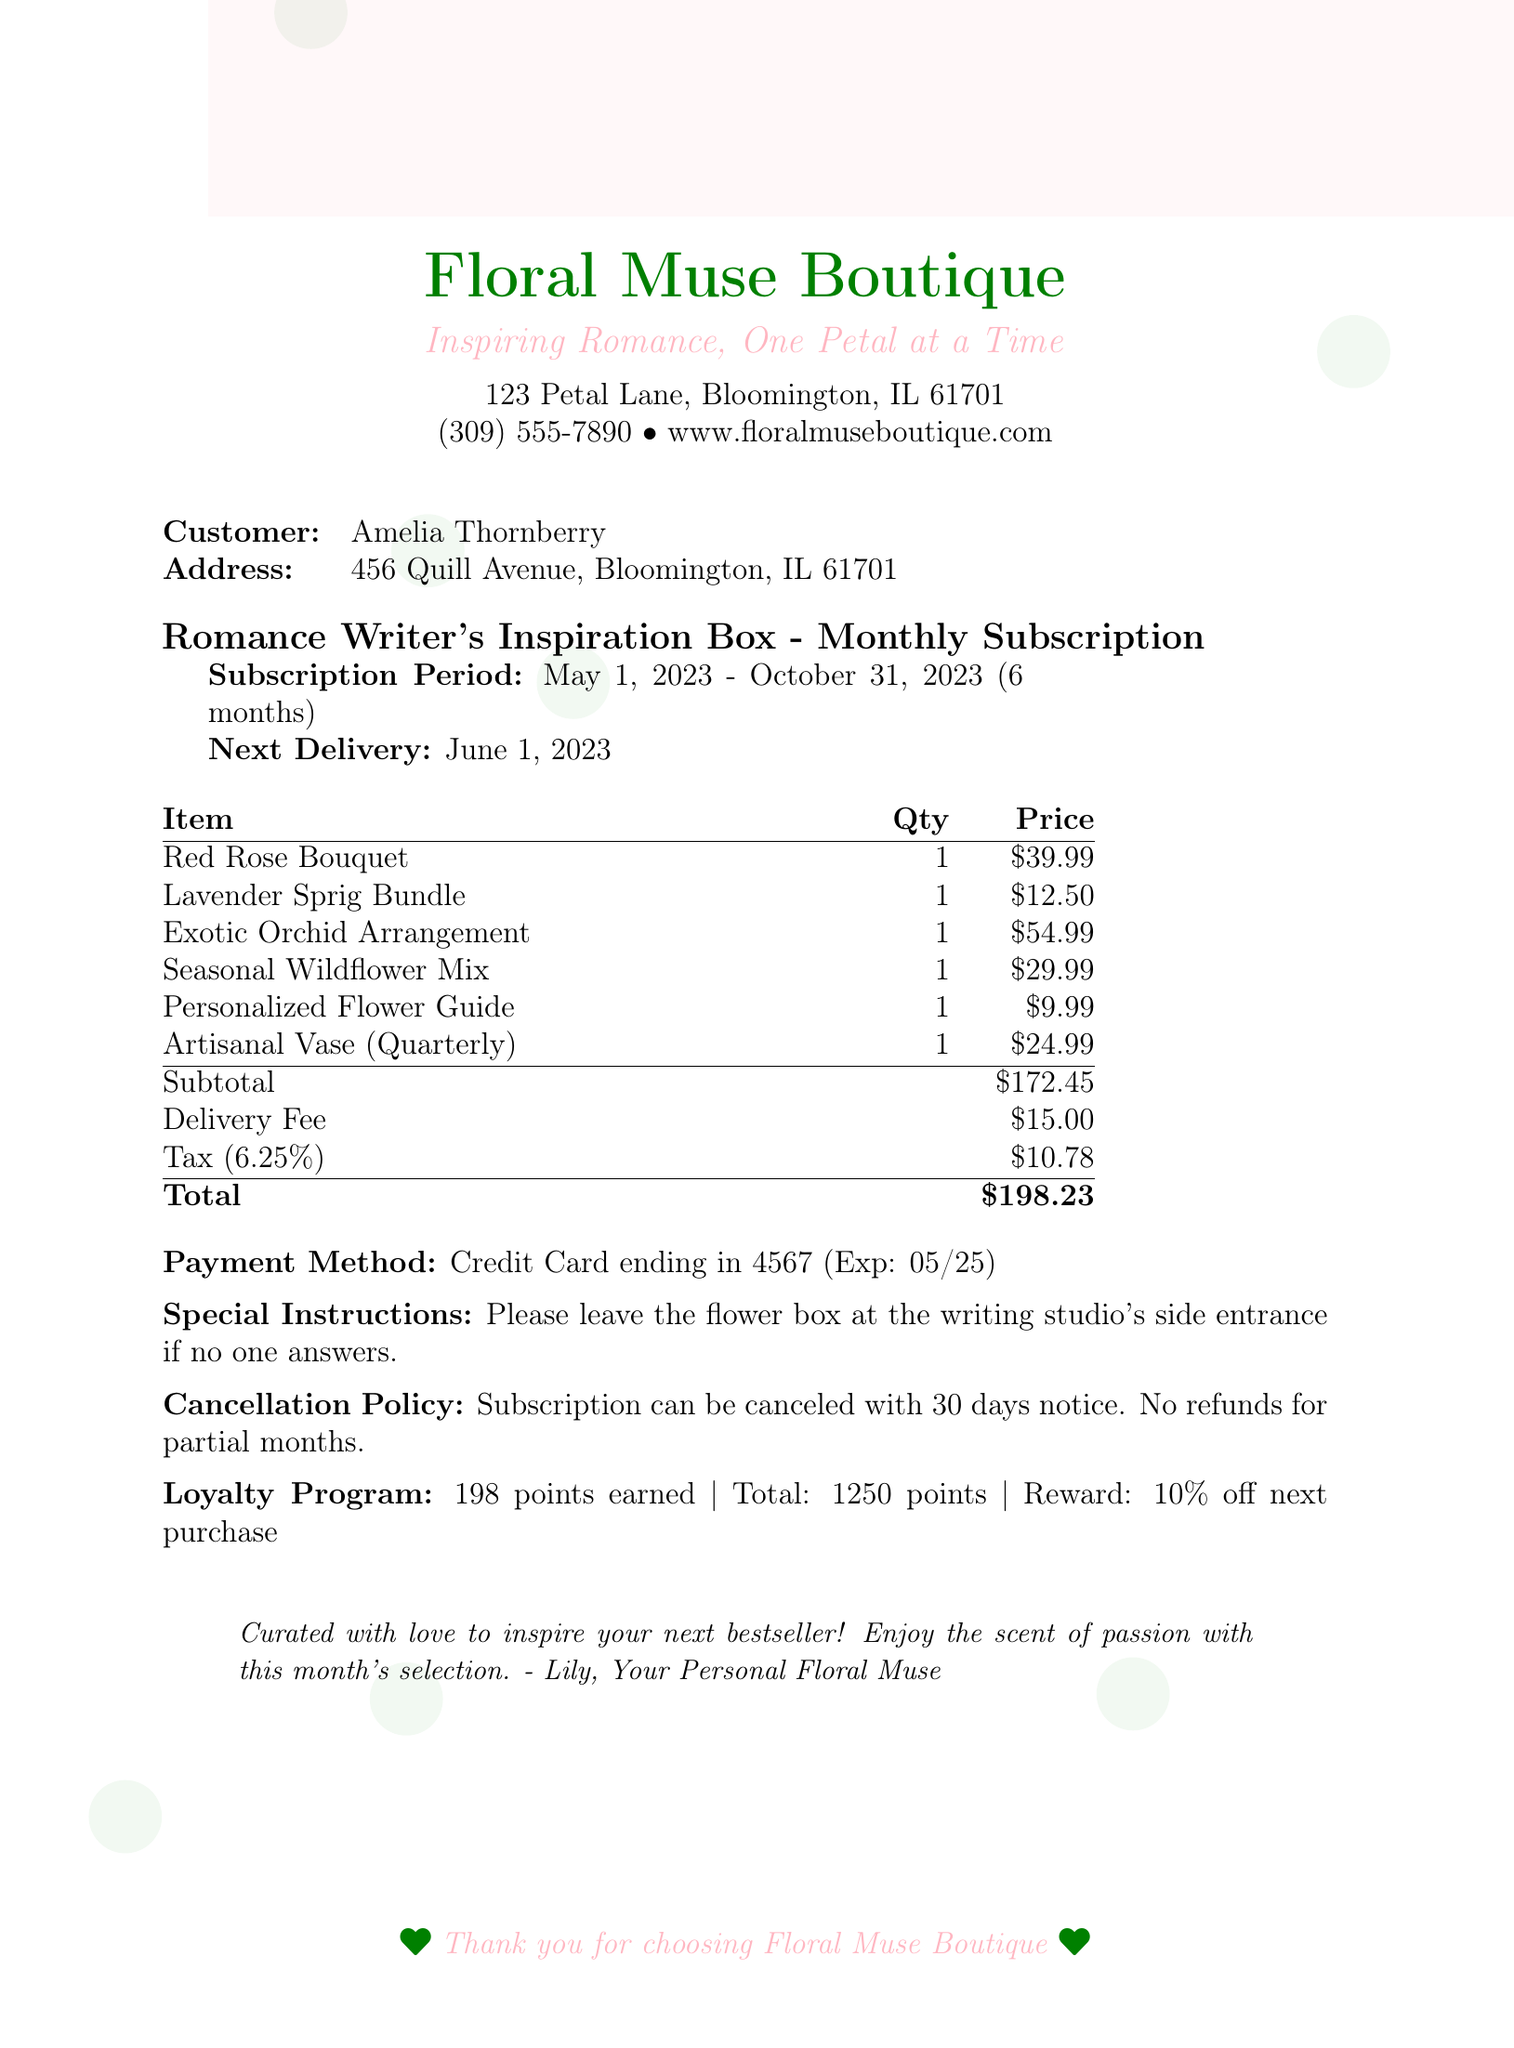What is the business name? The business name is listed at the top of the document.
Answer: Floral Muse Boutique What is the customer's address? The customer's address is mentioned in the section that identifies the customer.
Answer: 456 Quill Avenue, Bloomington, IL 61701 What is the subscription plan name? The subscription plan name is specified in the title of the subscription section.
Answer: Romance Writer's Inspiration Box What is the total amount charged? The total amount charged is found at the bottom of the pricing section.
Answer: $198.23 How many points were earned in the loyalty program? The points earned are indicated in the loyalty program section of the document.
Answer: 198 What is the cancellation notice period? The cancellation notice period is detailed in the cancellation policy section.
Answer: 30 days What is the next delivery date? The next delivery date is clearly stated in the subscription details.
Answer: June 1, 2023 What is included in the additional services? The additional services are listed separately, including a description of each item.
Answer: Personalized Flower Guide and Artisanal Vase Who is the florist note signed by? The florist note includes a signature at the end of the note section.
Answer: Lily What is the payment method used? The payment method is mentioned near the bottom of the document.
Answer: Credit Card 